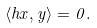Convert formula to latex. <formula><loc_0><loc_0><loc_500><loc_500>\langle h x , y \rangle = 0 .</formula> 